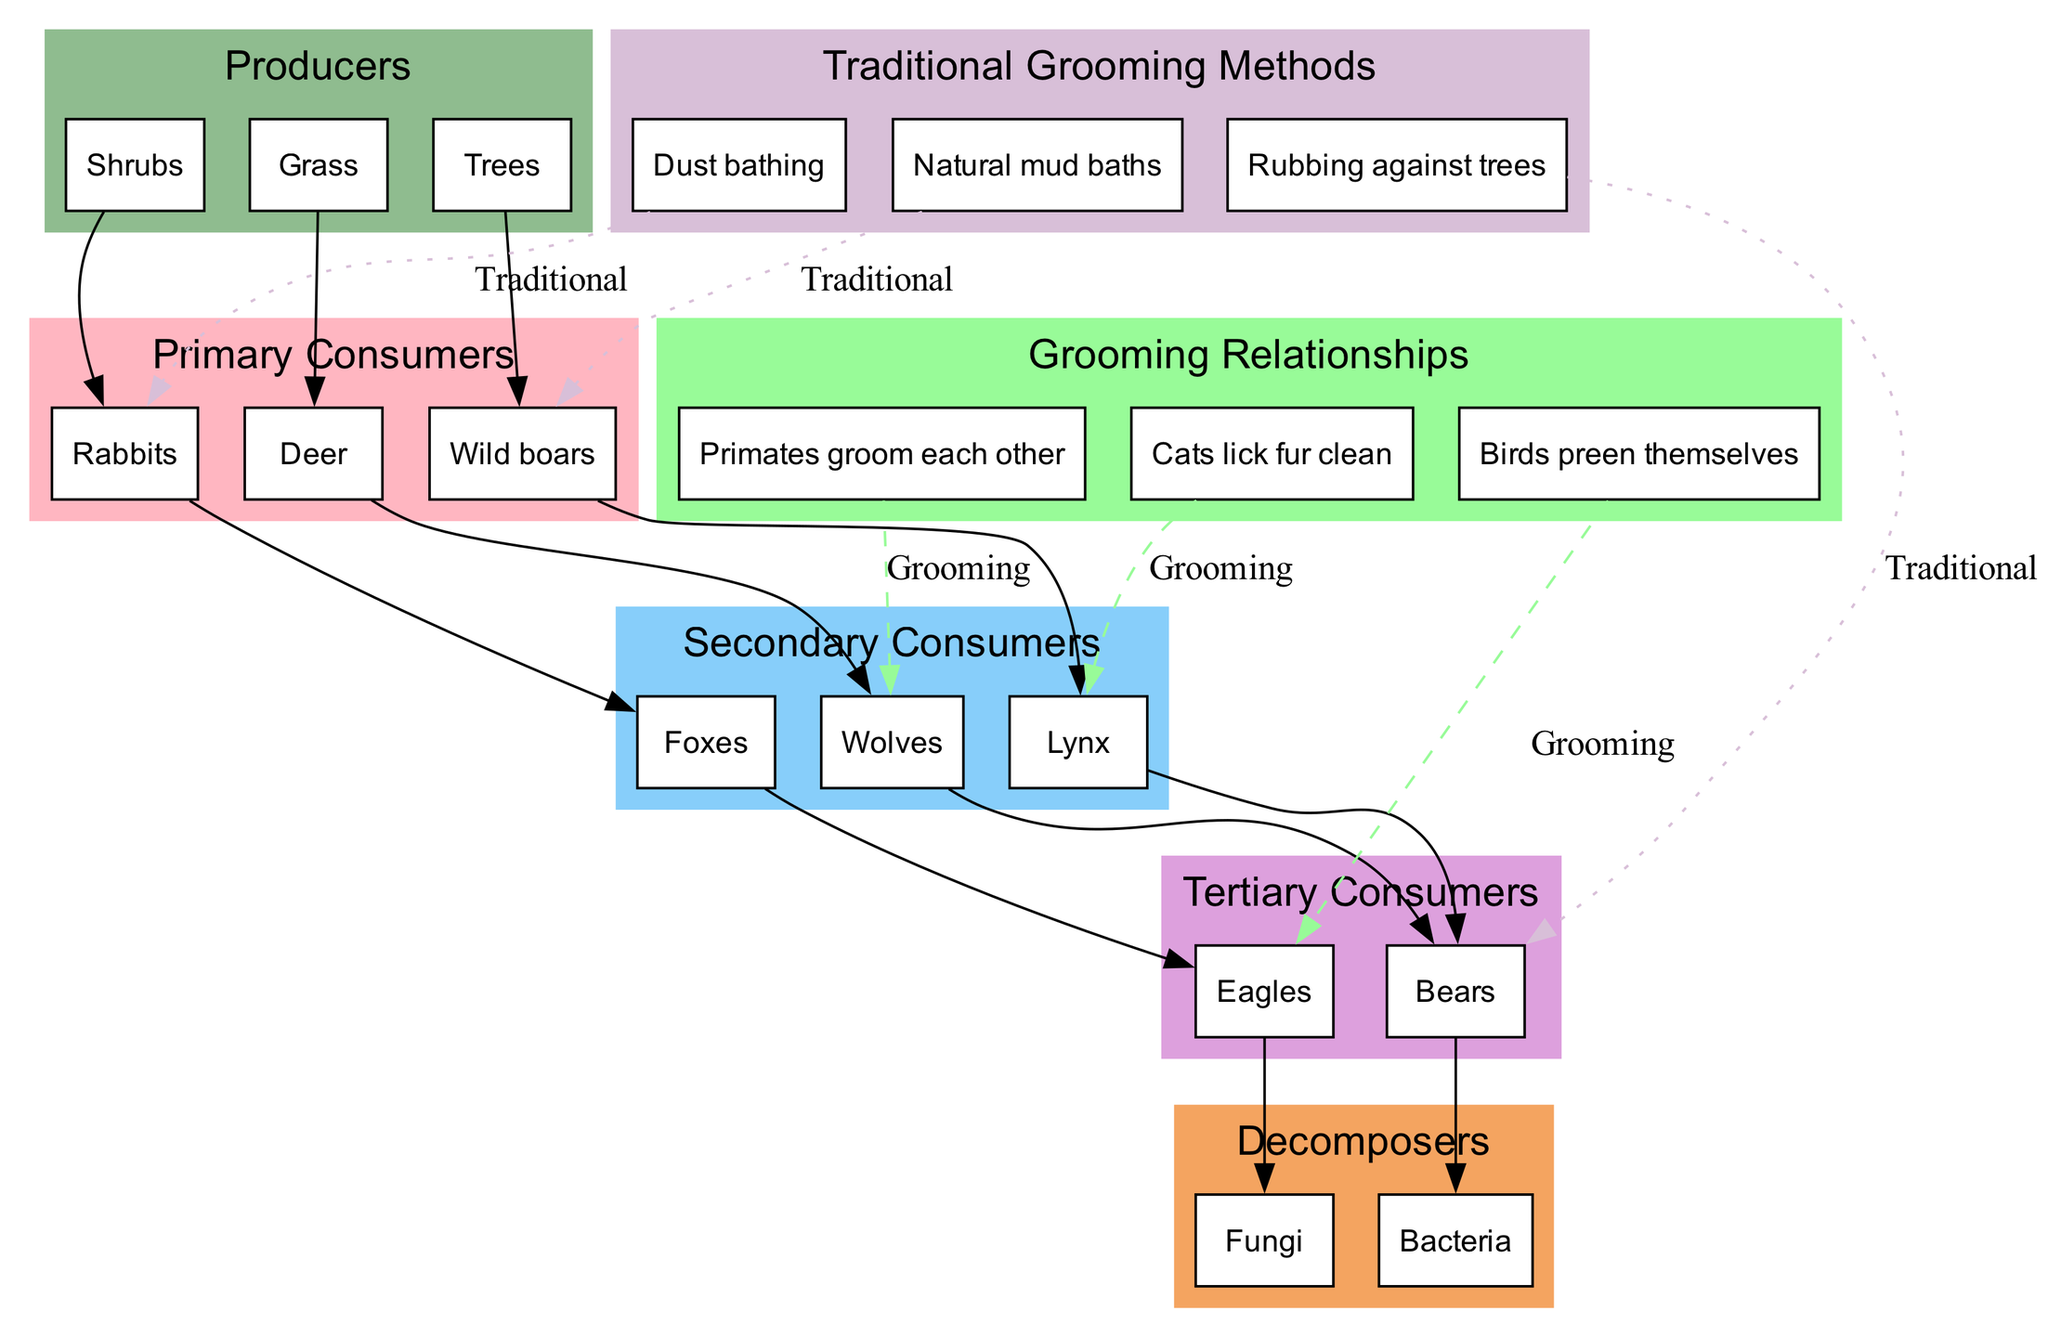What are the producers in this food chain? The producers in the food chain are Grass, Shrubs, and Trees. These are the first level of the food chain, providing energy for the primary consumers.
Answer: Grass, Shrubs, Trees How many primary consumers are there? There are three primary consumers: Deer, Rabbits, and Wild boars. This is counted directly from the primary consumers section of the diagram.
Answer: 3 Which animal is a secondary consumer that preys on rabbits? The animal that preys on rabbits is the Fox. This can be determined by visualizing the flow of energy from primary consumers (Rabbits) to secondary consumers (Foxes).
Answer: Fox What is the grooming relationship displayed between wolves and primates? The grooming relationship displayed is that Primates groom each other in relation to Wolves. This indicates a social grooming behavior linked to secondary consumers in the food chain.
Answer: Primates groom each other Which traditional grooming method involves Wild boars? The traditional grooming method that involves Wild boars is Natural mud baths. This is specifically indicated as a connection from the traditional grooming methods to the Wild boars in the diagram.
Answer: Natural mud baths Identify a tertiary consumer in this food chain. A tertiary consumer in this food chain is Bears. Tertiary consumers are those that feed on secondary consumers, and Bears are listed under that category in the diagram.
Answer: Bears How many decomposers are present in the diagram? There are two decomposers present: Bacteria and Fungi. This is seen directly in the decomposers section of the diagram.
Answer: 2 What does the dashed line signify in the diagram? The dashed line signifies grooming relationships in the food chain. It connects different species that engage in grooming behavior, distinguishing it from the solid lines that indicate direct food chain relationships.
Answer: Grooming relationships Which animal is shown to lick its fur clean as a traditional grooming method? The animal shown to lick its fur clean as a traditional grooming method is the Lynx. This is indicated in the traditional grooming methods section of the diagram related to the animal's behavior.
Answer: Lynx 